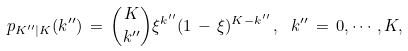<formula> <loc_0><loc_0><loc_500><loc_500>p _ { K ^ { \prime \prime } | K } ( k ^ { \prime \prime } ) \, = \, \binom { K } { k ^ { \prime \prime } } \xi ^ { k ^ { \prime \prime } } ( 1 \, - \, \xi ) ^ { K - k ^ { \prime \prime } } \, , \, \ k ^ { \prime \prime } \, = \, 0 , \cdots , K ,</formula> 